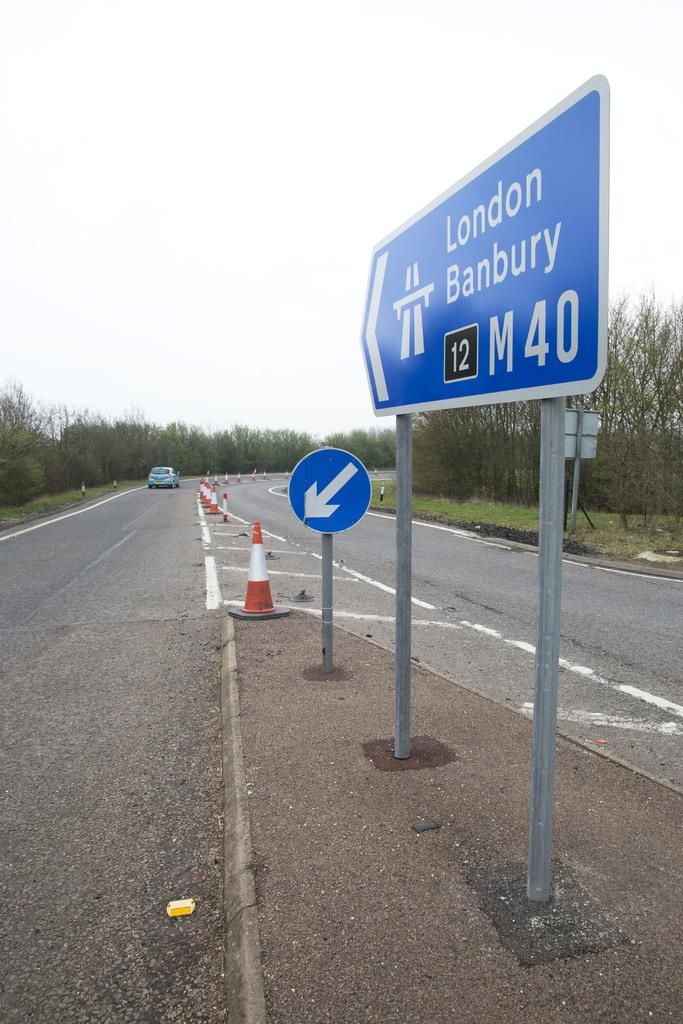<image>
Summarize the visual content of the image. A blue sign points to London Banbury and states, "M40" 